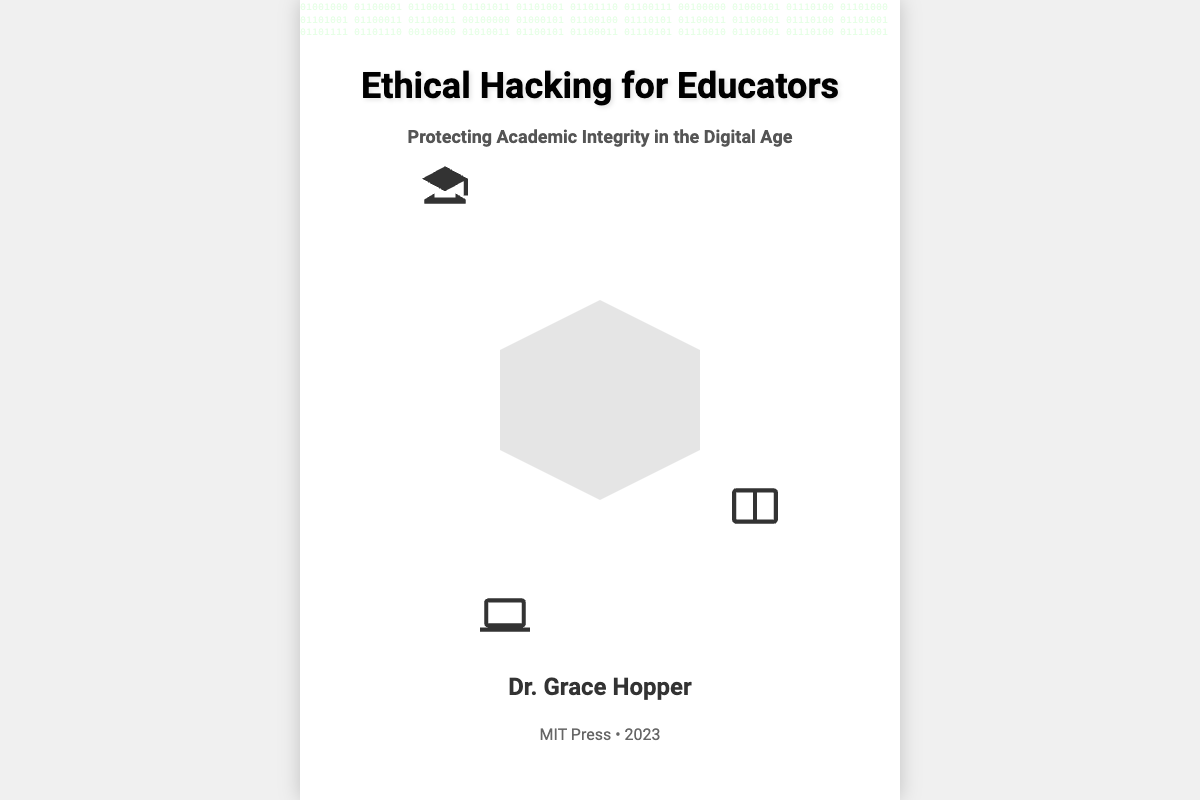What is the title of the book? The title of the book is prominently displayed at the top of the cover.
Answer: Ethical Hacking for Educators Who is the author of the book? The author's name is located near the bottom of the cover.
Answer: Dr. Grace Hopper What is the subtitle of the book? The subtitle provides additional context about the book's focus.
Answer: Protecting Academic Integrity in the Digital Age What is the publisher's name? The publisher's name is mentioned near the author's name.
Answer: MIT Press What year was the book published? The publication year is stated along with the publisher's name.
Answer: 2023 What color are the binary codes on the cover? The binary codes are styled and colored to fit the digital theme of the cover.
Answer: Green What type of icon is featured prominently on the cover? The central icon symbolizes protection and cybersecurity themes.
Answer: Shield How many educational symbols are visible on the cover? The cover displays educational symbols related to academic themes.
Answer: Three What font is used for the title? The title's font is distinctively chosen to convey authority and clarity.
Answer: Roboto 